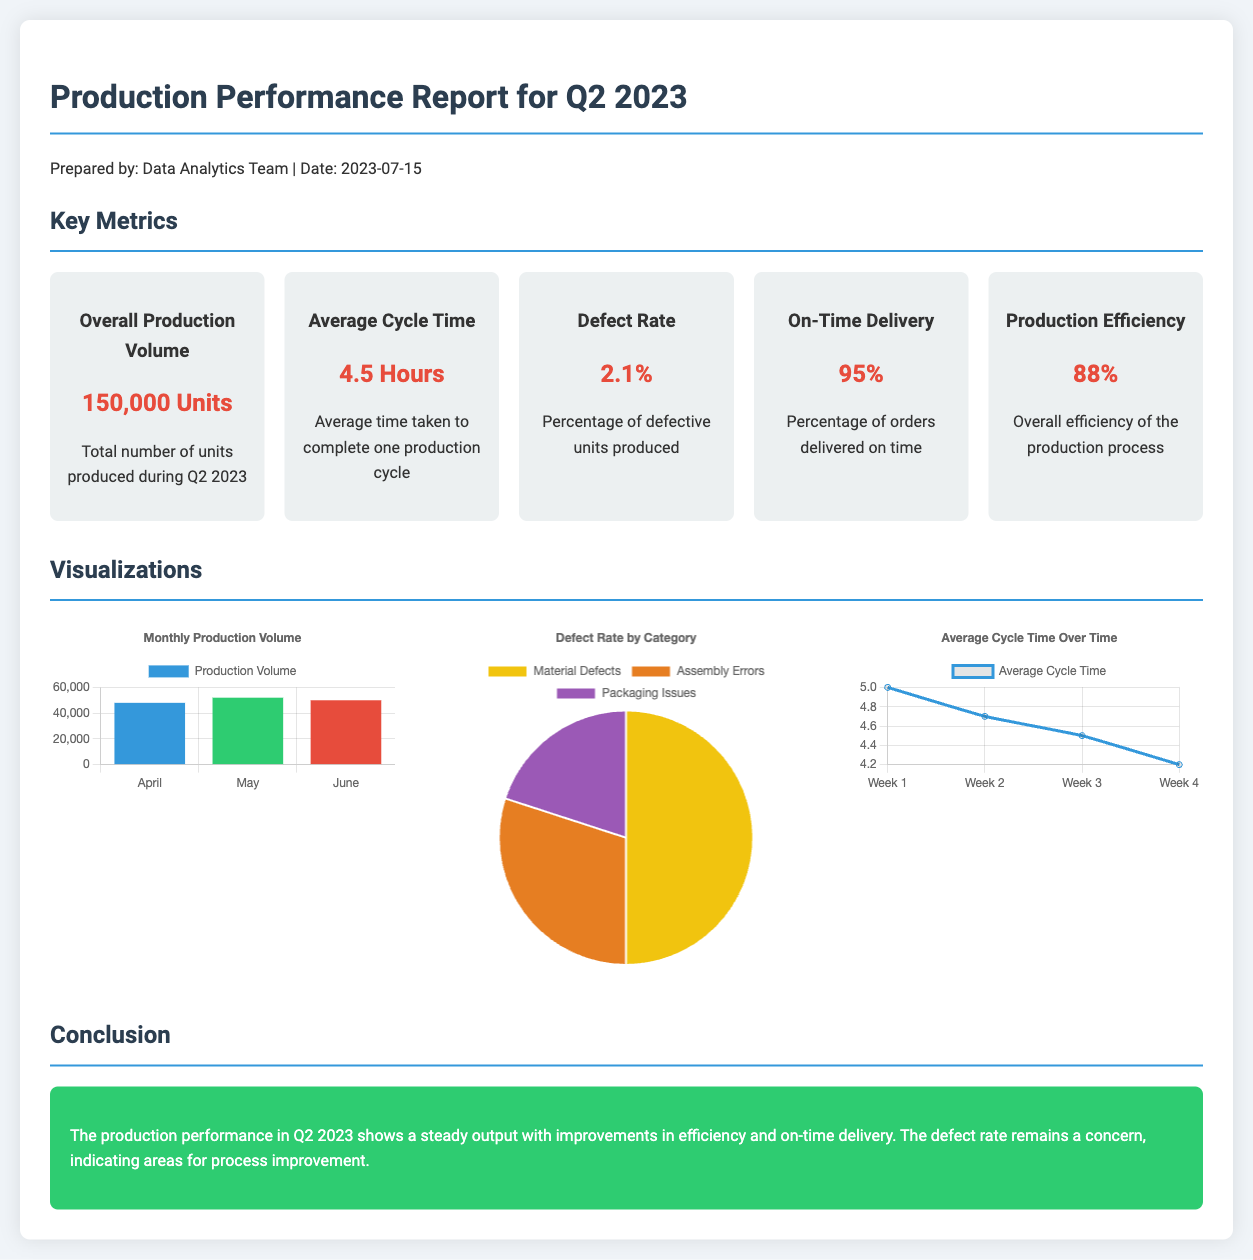What was the overall production volume in Q2 2023? The overall production volume is specified as 150,000 units produced during Q2 2023.
Answer: 150,000 Units What is the average cycle time mentioned in the report? The average cycle time is indicated as 4.5 hours for one production cycle.
Answer: 4.5 Hours What percentage of orders were delivered on time? The document states that 95% of orders were delivered on time.
Answer: 95% How many units were produced in May? The chart indicates that 52,000 units were produced in May.
Answer: 52,000 What is the defect rate reported for Q2 2023? The defect rate is reported as 2.1% in the document.
Answer: 2.1% Which month had the highest production volume? The highest production volume is shown in the chart for May with 52,000 units.
Answer: May What is the percentage of defect types due to assembly errors? The defect rate chart shows that 30% of defects are due to assembly errors.
Answer: 30% What trend is observed in average cycle time over the weeks? The average cycle time shows a decreasing trend over the weeks, as indicated by the line chart.
Answer: Decreasing What is the conclusion drawn from the production performance in Q2 2023? The conclusion notes steady output with improvements in efficiency and on-time delivery, but a concern over the defect rate.
Answer: Steady output with improvements 